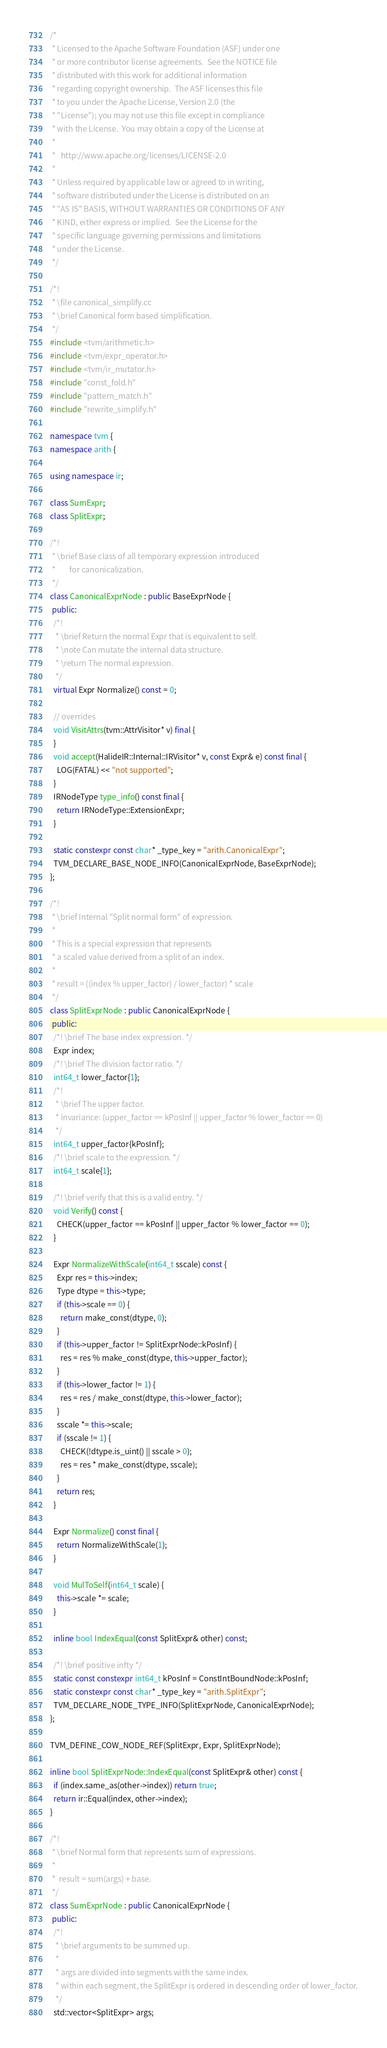<code> <loc_0><loc_0><loc_500><loc_500><_C++_>/*
 * Licensed to the Apache Software Foundation (ASF) under one
 * or more contributor license agreements.  See the NOTICE file
 * distributed with this work for additional information
 * regarding copyright ownership.  The ASF licenses this file
 * to you under the Apache License, Version 2.0 (the
 * "License"); you may not use this file except in compliance
 * with the License.  You may obtain a copy of the License at
 *
 *   http://www.apache.org/licenses/LICENSE-2.0
 *
 * Unless required by applicable law or agreed to in writing,
 * software distributed under the License is distributed on an
 * "AS IS" BASIS, WITHOUT WARRANTIES OR CONDITIONS OF ANY
 * KIND, either express or implied.  See the License for the
 * specific language governing permissions and limitations
 * under the License.
 */

/*!
 * \file canonical_simplify.cc
 * \brief Canonical form based simplification.
 */
#include <tvm/arithmetic.h>
#include <tvm/expr_operator.h>
#include <tvm/ir_mutator.h>
#include "const_fold.h"
#include "pattern_match.h"
#include "rewrite_simplify.h"

namespace tvm {
namespace arith {

using namespace ir;

class SumExpr;
class SplitExpr;

/*!
 * \brief Base class of all temporary expression introduced
 *        for canonicalization.
 */
class CanonicalExprNode : public BaseExprNode {
 public:
  /*!
   * \brief Return the normal Expr that is equivalent to self.
   * \note Can mutate the internal data structure.
   * \return The normal expression.
   */
  virtual Expr Normalize() const = 0;

  // overrides
  void VisitAttrs(tvm::AttrVisitor* v) final {
  }
  void accept(HalideIR::Internal::IRVisitor* v, const Expr& e) const final {
    LOG(FATAL) << "not supported";
  }
  IRNodeType type_info() const final {
    return IRNodeType::ExtensionExpr;
  }

  static constexpr const char* _type_key = "arith.CanonicalExpr";
  TVM_DECLARE_BASE_NODE_INFO(CanonicalExprNode, BaseExprNode);
};

/*!
 * \brief Internal "Split normal form" of expression.
 *
 * This is a special expression that represents
 * a scaled value derived from a split of an index.
 *
 * result = ((index % upper_factor) / lower_factor) * scale
 */
class SplitExprNode : public CanonicalExprNode {
 public:
  /*! \brief The base index expression. */
  Expr index;
  /*! \brief The division factor ratio. */
  int64_t lower_factor{1};
  /*!
   * \brief The upper factor.
   * invariance: (upper_factor == kPosInf || upper_factor % lower_factor == 0)
   */
  int64_t upper_factor{kPosInf};
  /*! \brief scale to the expression. */
  int64_t scale{1};

  /*! \brief verify that this is a valid entry. */
  void Verify() const {
    CHECK(upper_factor == kPosInf || upper_factor % lower_factor == 0);
  }

  Expr NormalizeWithScale(int64_t sscale) const {
    Expr res = this->index;
    Type dtype = this->type;
    if (this->scale == 0) {
      return make_const(dtype, 0);
    }
    if (this->upper_factor != SplitExprNode::kPosInf) {
      res = res % make_const(dtype, this->upper_factor);
    }
    if (this->lower_factor != 1) {
      res = res / make_const(dtype, this->lower_factor);
    }
    sscale *= this->scale;
    if (sscale != 1) {
      CHECK(!dtype.is_uint() || sscale > 0);
      res = res * make_const(dtype, sscale);
    }
    return res;
  }

  Expr Normalize() const final {
    return NormalizeWithScale(1);
  }

  void MulToSelf(int64_t scale) {
    this->scale *= scale;
  }

  inline bool IndexEqual(const SplitExpr& other) const;

  /*! \brief positive infty */
  static const constexpr int64_t kPosInf = ConstIntBoundNode::kPosInf;
  static constexpr const char* _type_key = "arith.SplitExpr";
  TVM_DECLARE_NODE_TYPE_INFO(SplitExprNode, CanonicalExprNode);
};

TVM_DEFINE_COW_NODE_REF(SplitExpr, Expr, SplitExprNode);

inline bool SplitExprNode::IndexEqual(const SplitExpr& other) const {
  if (index.same_as(other->index)) return true;
  return ir::Equal(index, other->index);
}

/*!
 * \brief Normal form that represents sum of expressions.
 *
 *  result = sum(args) + base.
 */
class SumExprNode : public CanonicalExprNode {
 public:
  /*!
   * \brief arguments to be summed up.
   *
   * args are divided into segments with the same index.
   * within each segment, the SplitExpr is ordered in descending order of lower_factor.
   */
  std::vector<SplitExpr> args;</code> 